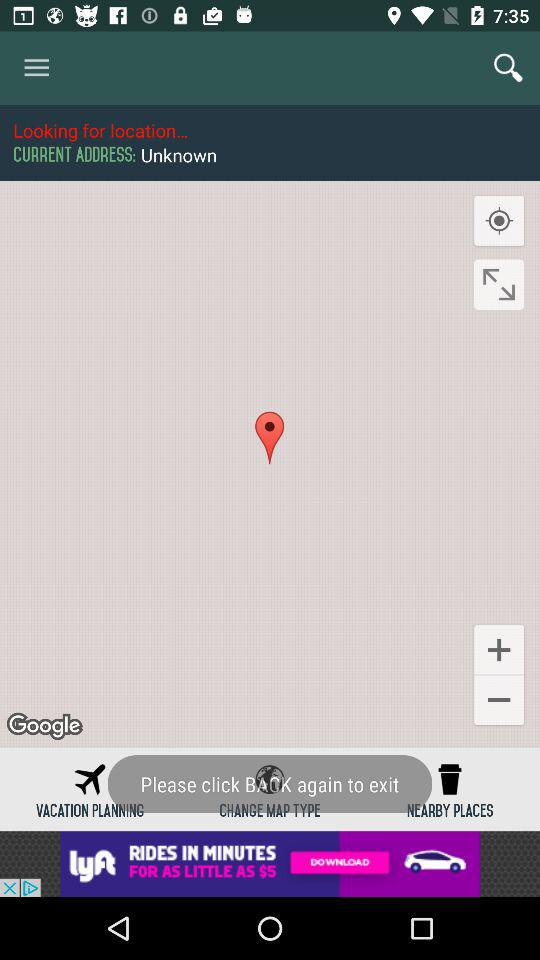How many places are nearby?
When the provided information is insufficient, respond with <no answer>. <no answer> 